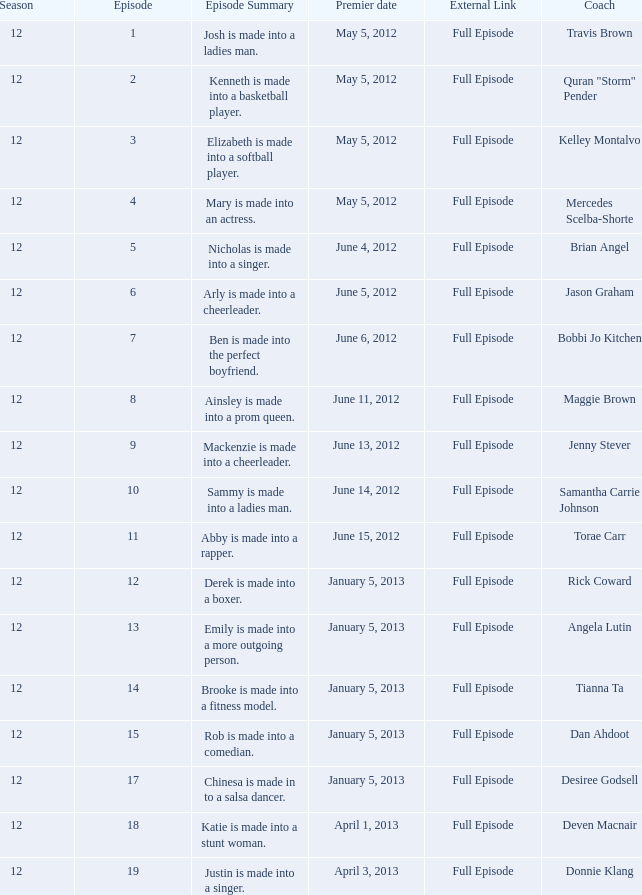Who is the trainer that helps emily become a more outgoing personality? Angela Lutin. 